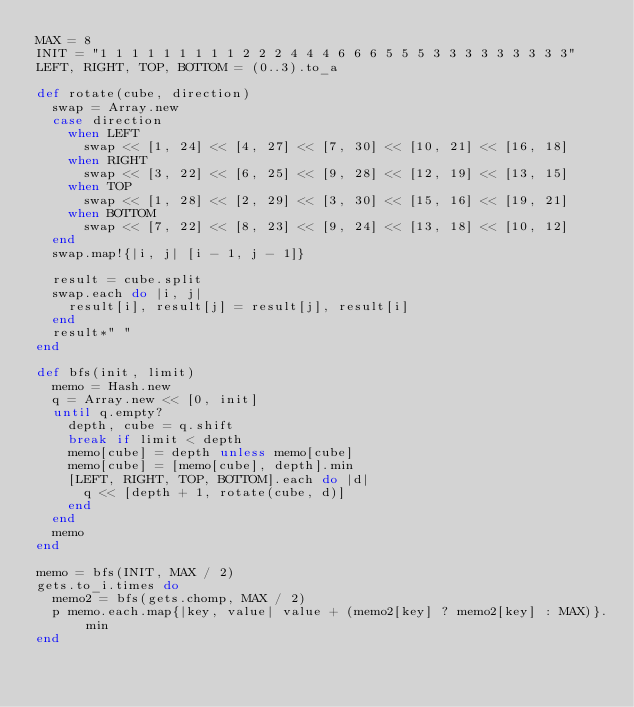Convert code to text. <code><loc_0><loc_0><loc_500><loc_500><_Ruby_>MAX = 8
INIT = "1 1 1 1 1 1 1 1 1 2 2 2 4 4 4 6 6 6 5 5 5 3 3 3 3 3 3 3 3 3"
LEFT, RIGHT, TOP, BOTTOM = (0..3).to_a

def rotate(cube, direction)
  swap = Array.new
  case direction
    when LEFT
      swap << [1, 24] << [4, 27] << [7, 30] << [10, 21] << [16, 18]
    when RIGHT
      swap << [3, 22] << [6, 25] << [9, 28] << [12, 19] << [13, 15]
    when TOP
      swap << [1, 28] << [2, 29] << [3, 30] << [15, 16] << [19, 21]
    when BOTTOM
      swap << [7, 22] << [8, 23] << [9, 24] << [13, 18] << [10, 12]
  end
  swap.map!{|i, j| [i - 1, j - 1]}

  result = cube.split
  swap.each do |i, j|
    result[i], result[j] = result[j], result[i]
  end
  result*" "
end

def bfs(init, limit)
  memo = Hash.new
  q = Array.new << [0, init]
  until q.empty?
    depth, cube = q.shift
    break if limit < depth
    memo[cube] = depth unless memo[cube]
    memo[cube] = [memo[cube], depth].min
    [LEFT, RIGHT, TOP, BOTTOM].each do |d|
      q << [depth + 1, rotate(cube, d)]
    end
  end
  memo
end

memo = bfs(INIT, MAX / 2)
gets.to_i.times do
  memo2 = bfs(gets.chomp, MAX / 2)
  p memo.each.map{|key, value| value + (memo2[key] ? memo2[key] : MAX)}.min
end</code> 